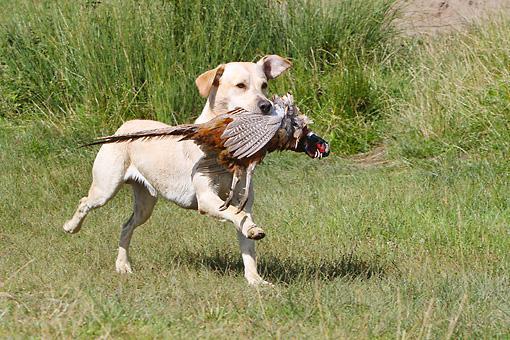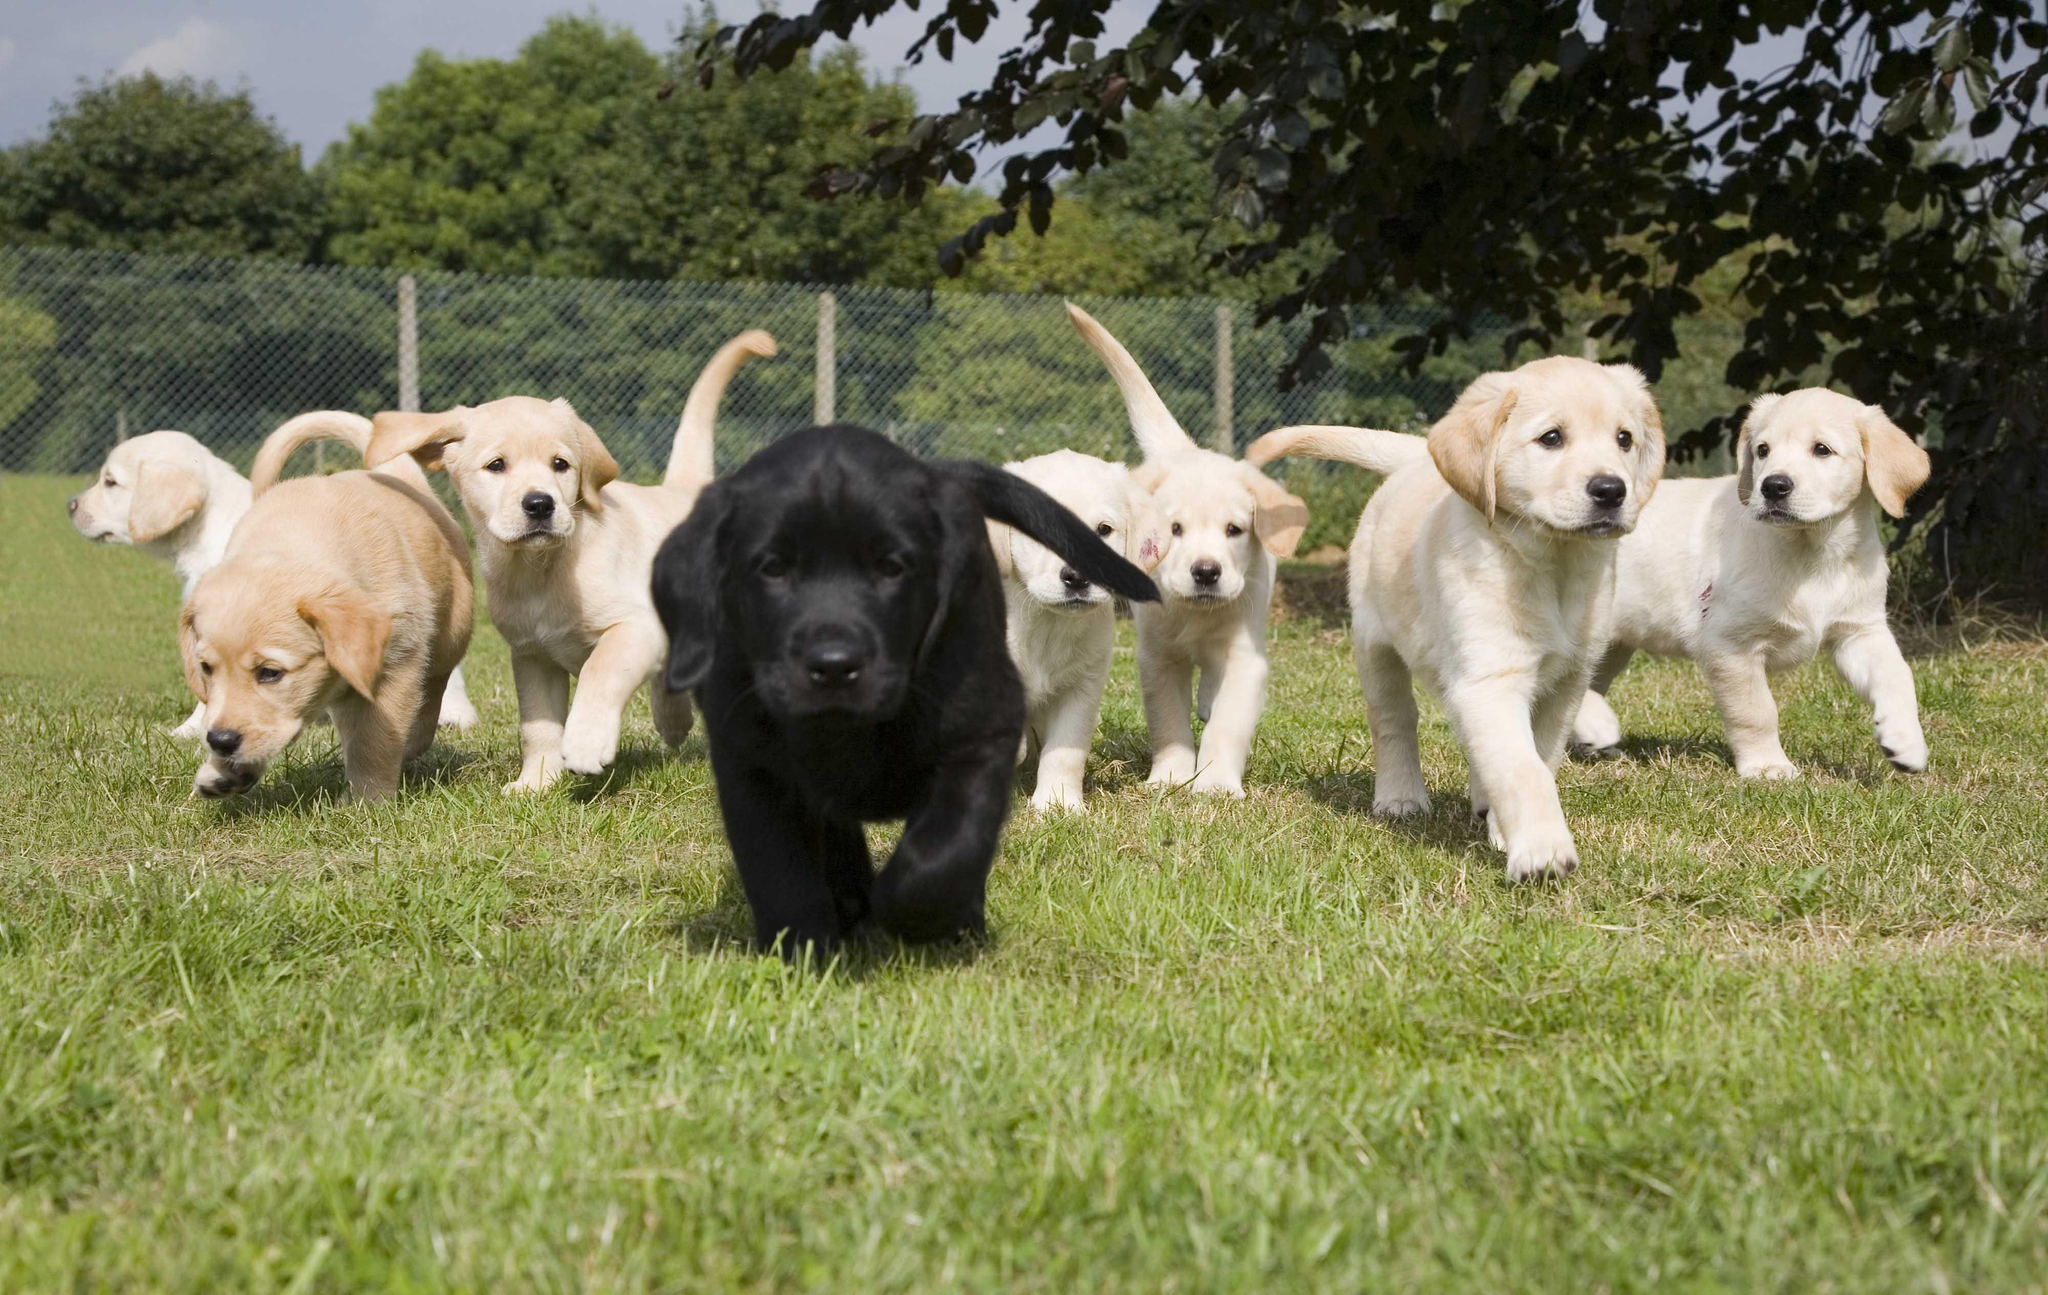The first image is the image on the left, the second image is the image on the right. For the images shown, is this caption "More than half a dozen dogs are lined up in each image." true? Answer yes or no. No. The first image is the image on the left, the second image is the image on the right. Given the left and right images, does the statement "An image includes a hunting dog and a captured prey bird." hold true? Answer yes or no. Yes. 